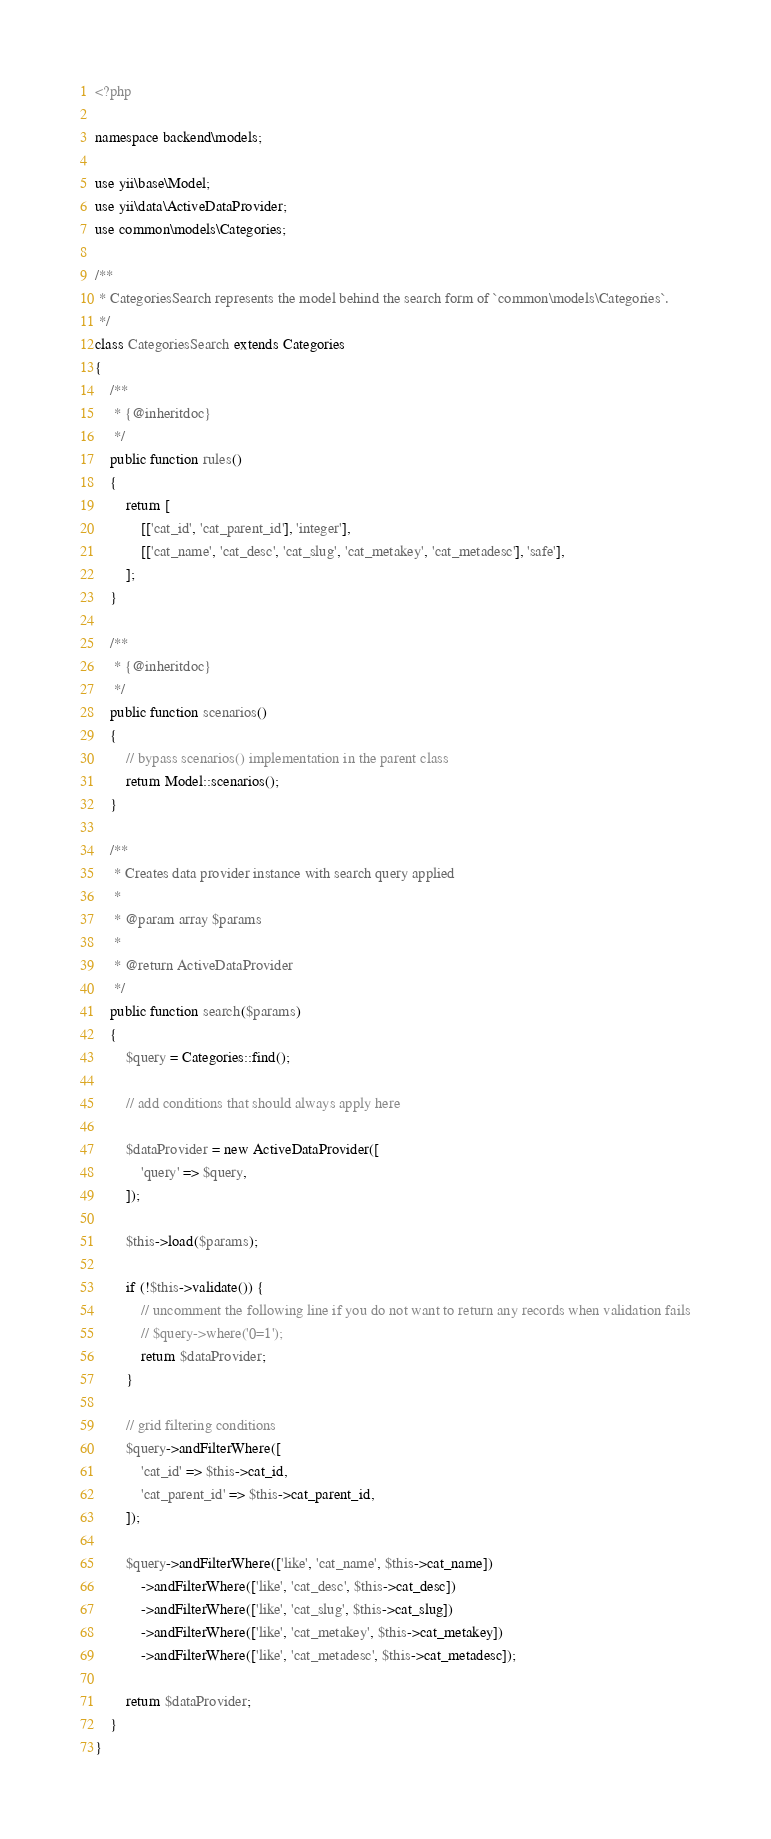Convert code to text. <code><loc_0><loc_0><loc_500><loc_500><_PHP_><?php

namespace backend\models;

use yii\base\Model;
use yii\data\ActiveDataProvider;
use common\models\Categories;

/**
 * CategoriesSearch represents the model behind the search form of `common\models\Categories`.
 */
class CategoriesSearch extends Categories
{
    /**
     * {@inheritdoc}
     */
    public function rules()
    {
        return [
            [['cat_id', 'cat_parent_id'], 'integer'],
            [['cat_name', 'cat_desc', 'cat_slug', 'cat_metakey', 'cat_metadesc'], 'safe'],
        ];
    }

    /**
     * {@inheritdoc}
     */
    public function scenarios()
    {
        // bypass scenarios() implementation in the parent class
        return Model::scenarios();
    }

    /**
     * Creates data provider instance with search query applied
     *
     * @param array $params
     *
     * @return ActiveDataProvider
     */
    public function search($params)
    {
        $query = Categories::find();

        // add conditions that should always apply here

        $dataProvider = new ActiveDataProvider([
            'query' => $query,
        ]);

        $this->load($params);

        if (!$this->validate()) {
            // uncomment the following line if you do not want to return any records when validation fails
            // $query->where('0=1');
            return $dataProvider;
        }

        // grid filtering conditions
        $query->andFilterWhere([
            'cat_id' => $this->cat_id,
            'cat_parent_id' => $this->cat_parent_id,
        ]);

        $query->andFilterWhere(['like', 'cat_name', $this->cat_name])
            ->andFilterWhere(['like', 'cat_desc', $this->cat_desc])
            ->andFilterWhere(['like', 'cat_slug', $this->cat_slug])
            ->andFilterWhere(['like', 'cat_metakey', $this->cat_metakey])
            ->andFilterWhere(['like', 'cat_metadesc', $this->cat_metadesc]);

        return $dataProvider;
    }
}
</code> 